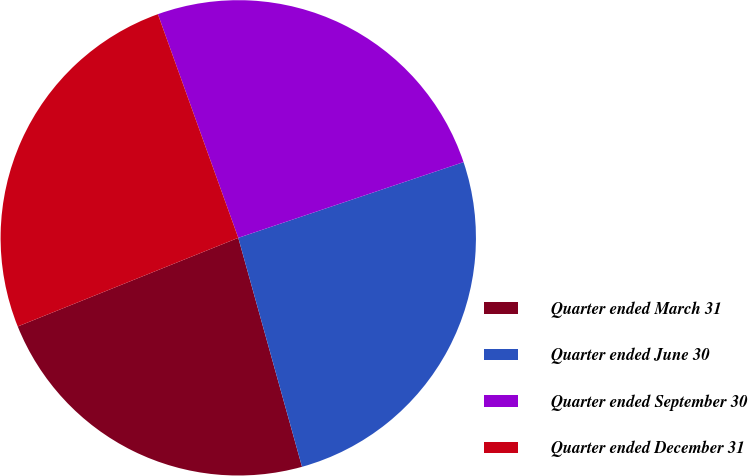Convert chart. <chart><loc_0><loc_0><loc_500><loc_500><pie_chart><fcel>Quarter ended March 31<fcel>Quarter ended June 30<fcel>Quarter ended September 30<fcel>Quarter ended December 31<nl><fcel>23.24%<fcel>25.84%<fcel>25.33%<fcel>25.59%<nl></chart> 